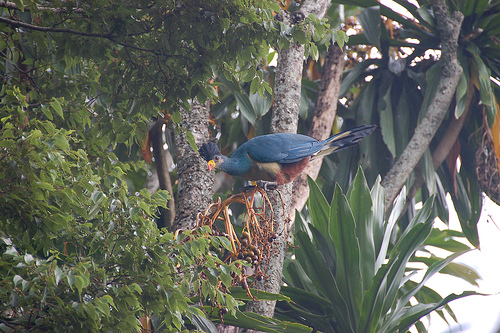<image>
Is the tree on the bird? No. The tree is not positioned on the bird. They may be near each other, but the tree is not supported by or resting on top of the bird. Is there a bird under the leaf? Yes. The bird is positioned underneath the leaf, with the leaf above it in the vertical space. 